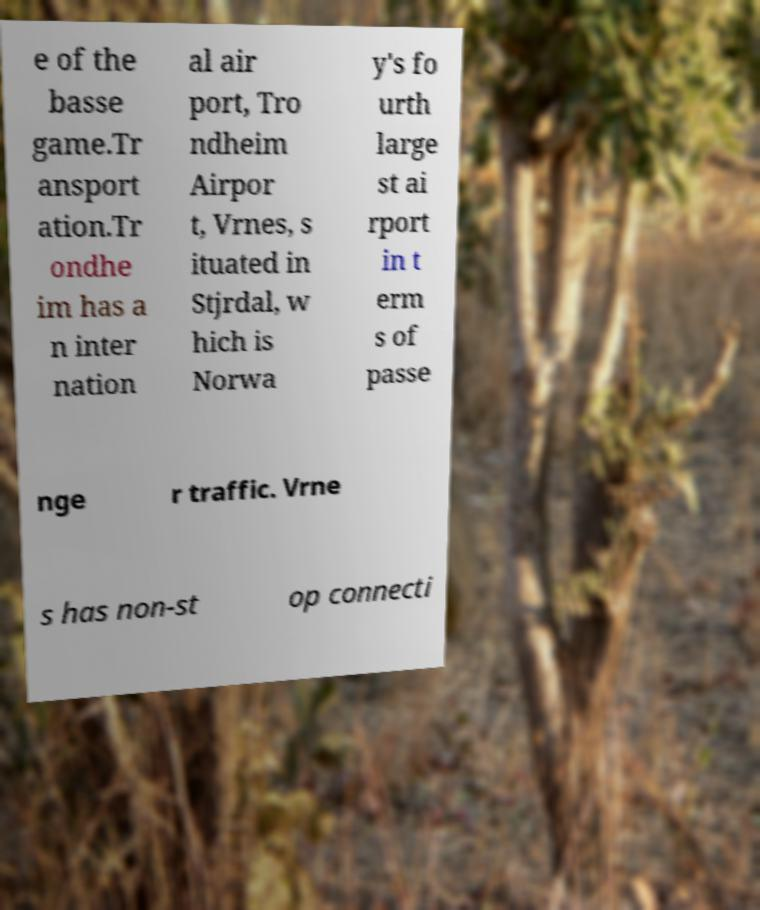Could you assist in decoding the text presented in this image and type it out clearly? e of the basse game.Tr ansport ation.Tr ondhe im has a n inter nation al air port, Tro ndheim Airpor t, Vrnes, s ituated in Stjrdal, w hich is Norwa y's fo urth large st ai rport in t erm s of passe nge r traffic. Vrne s has non-st op connecti 